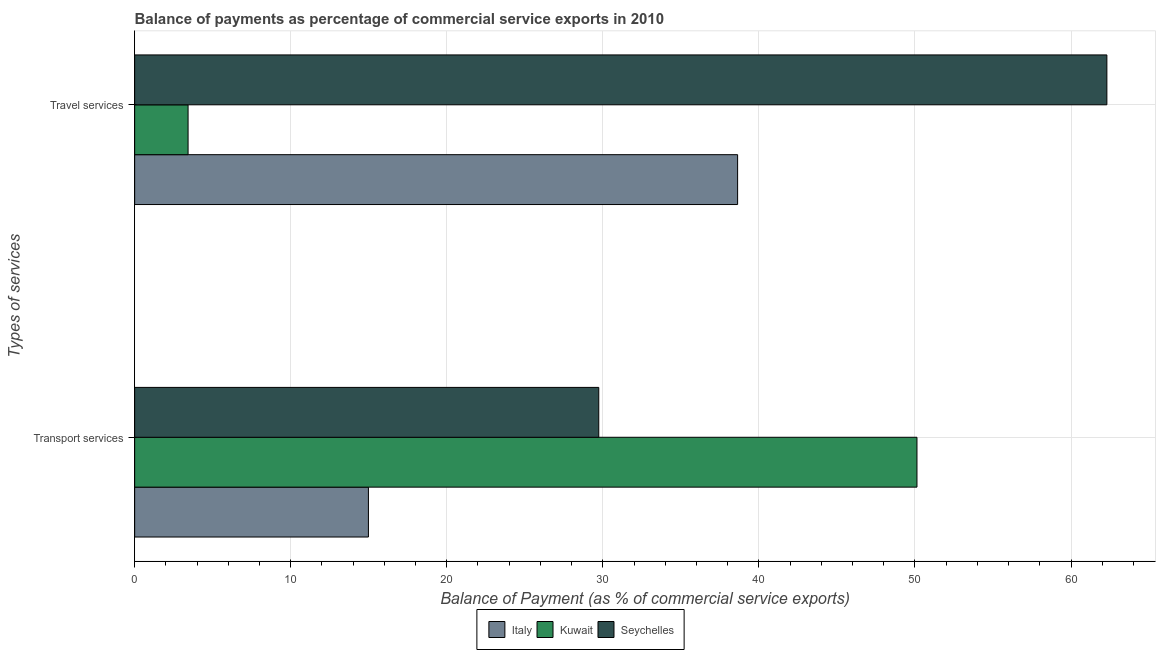How many different coloured bars are there?
Ensure brevity in your answer.  3. How many groups of bars are there?
Your answer should be very brief. 2. Are the number of bars per tick equal to the number of legend labels?
Provide a succinct answer. Yes. Are the number of bars on each tick of the Y-axis equal?
Keep it short and to the point. Yes. How many bars are there on the 2nd tick from the top?
Make the answer very short. 3. What is the label of the 2nd group of bars from the top?
Your answer should be very brief. Transport services. What is the balance of payments of travel services in Seychelles?
Ensure brevity in your answer.  62.3. Across all countries, what is the maximum balance of payments of travel services?
Offer a terse response. 62.3. Across all countries, what is the minimum balance of payments of transport services?
Offer a very short reply. 14.98. In which country was the balance of payments of travel services maximum?
Your answer should be compact. Seychelles. In which country was the balance of payments of travel services minimum?
Provide a short and direct response. Kuwait. What is the total balance of payments of travel services in the graph?
Offer a terse response. 104.36. What is the difference between the balance of payments of travel services in Italy and that in Seychelles?
Your answer should be very brief. -23.66. What is the difference between the balance of payments of transport services in Kuwait and the balance of payments of travel services in Seychelles?
Offer a very short reply. -12.17. What is the average balance of payments of travel services per country?
Provide a succinct answer. 34.79. What is the difference between the balance of payments of travel services and balance of payments of transport services in Seychelles?
Provide a short and direct response. 32.56. What is the ratio of the balance of payments of travel services in Kuwait to that in Seychelles?
Offer a very short reply. 0.05. In how many countries, is the balance of payments of travel services greater than the average balance of payments of travel services taken over all countries?
Provide a succinct answer. 2. What does the 2nd bar from the top in Travel services represents?
Offer a very short reply. Kuwait. What does the 3rd bar from the bottom in Travel services represents?
Provide a succinct answer. Seychelles. How many bars are there?
Offer a very short reply. 6. Are all the bars in the graph horizontal?
Provide a short and direct response. Yes. How many countries are there in the graph?
Make the answer very short. 3. Does the graph contain any zero values?
Keep it short and to the point. No. Where does the legend appear in the graph?
Provide a succinct answer. Bottom center. What is the title of the graph?
Your answer should be very brief. Balance of payments as percentage of commercial service exports in 2010. What is the label or title of the X-axis?
Your response must be concise. Balance of Payment (as % of commercial service exports). What is the label or title of the Y-axis?
Offer a terse response. Types of services. What is the Balance of Payment (as % of commercial service exports) in Italy in Transport services?
Provide a short and direct response. 14.98. What is the Balance of Payment (as % of commercial service exports) in Kuwait in Transport services?
Give a very brief answer. 50.13. What is the Balance of Payment (as % of commercial service exports) in Seychelles in Transport services?
Your answer should be compact. 29.74. What is the Balance of Payment (as % of commercial service exports) in Italy in Travel services?
Ensure brevity in your answer.  38.64. What is the Balance of Payment (as % of commercial service exports) in Kuwait in Travel services?
Give a very brief answer. 3.42. What is the Balance of Payment (as % of commercial service exports) in Seychelles in Travel services?
Your answer should be compact. 62.3. Across all Types of services, what is the maximum Balance of Payment (as % of commercial service exports) of Italy?
Offer a terse response. 38.64. Across all Types of services, what is the maximum Balance of Payment (as % of commercial service exports) in Kuwait?
Provide a succinct answer. 50.13. Across all Types of services, what is the maximum Balance of Payment (as % of commercial service exports) of Seychelles?
Your response must be concise. 62.3. Across all Types of services, what is the minimum Balance of Payment (as % of commercial service exports) in Italy?
Make the answer very short. 14.98. Across all Types of services, what is the minimum Balance of Payment (as % of commercial service exports) in Kuwait?
Ensure brevity in your answer.  3.42. Across all Types of services, what is the minimum Balance of Payment (as % of commercial service exports) in Seychelles?
Give a very brief answer. 29.74. What is the total Balance of Payment (as % of commercial service exports) in Italy in the graph?
Offer a very short reply. 53.62. What is the total Balance of Payment (as % of commercial service exports) in Kuwait in the graph?
Your response must be concise. 53.55. What is the total Balance of Payment (as % of commercial service exports) of Seychelles in the graph?
Provide a succinct answer. 92.04. What is the difference between the Balance of Payment (as % of commercial service exports) of Italy in Transport services and that in Travel services?
Keep it short and to the point. -23.66. What is the difference between the Balance of Payment (as % of commercial service exports) of Kuwait in Transport services and that in Travel services?
Your answer should be very brief. 46.7. What is the difference between the Balance of Payment (as % of commercial service exports) of Seychelles in Transport services and that in Travel services?
Offer a terse response. -32.56. What is the difference between the Balance of Payment (as % of commercial service exports) of Italy in Transport services and the Balance of Payment (as % of commercial service exports) of Kuwait in Travel services?
Provide a short and direct response. 11.56. What is the difference between the Balance of Payment (as % of commercial service exports) in Italy in Transport services and the Balance of Payment (as % of commercial service exports) in Seychelles in Travel services?
Make the answer very short. -47.32. What is the difference between the Balance of Payment (as % of commercial service exports) in Kuwait in Transport services and the Balance of Payment (as % of commercial service exports) in Seychelles in Travel services?
Provide a short and direct response. -12.17. What is the average Balance of Payment (as % of commercial service exports) in Italy per Types of services?
Ensure brevity in your answer.  26.81. What is the average Balance of Payment (as % of commercial service exports) of Kuwait per Types of services?
Your response must be concise. 26.78. What is the average Balance of Payment (as % of commercial service exports) of Seychelles per Types of services?
Ensure brevity in your answer.  46.02. What is the difference between the Balance of Payment (as % of commercial service exports) in Italy and Balance of Payment (as % of commercial service exports) in Kuwait in Transport services?
Offer a very short reply. -35.15. What is the difference between the Balance of Payment (as % of commercial service exports) in Italy and Balance of Payment (as % of commercial service exports) in Seychelles in Transport services?
Provide a succinct answer. -14.76. What is the difference between the Balance of Payment (as % of commercial service exports) of Kuwait and Balance of Payment (as % of commercial service exports) of Seychelles in Transport services?
Give a very brief answer. 20.39. What is the difference between the Balance of Payment (as % of commercial service exports) in Italy and Balance of Payment (as % of commercial service exports) in Kuwait in Travel services?
Your answer should be very brief. 35.21. What is the difference between the Balance of Payment (as % of commercial service exports) in Italy and Balance of Payment (as % of commercial service exports) in Seychelles in Travel services?
Keep it short and to the point. -23.66. What is the difference between the Balance of Payment (as % of commercial service exports) of Kuwait and Balance of Payment (as % of commercial service exports) of Seychelles in Travel services?
Give a very brief answer. -58.87. What is the ratio of the Balance of Payment (as % of commercial service exports) in Italy in Transport services to that in Travel services?
Make the answer very short. 0.39. What is the ratio of the Balance of Payment (as % of commercial service exports) of Kuwait in Transport services to that in Travel services?
Give a very brief answer. 14.64. What is the ratio of the Balance of Payment (as % of commercial service exports) in Seychelles in Transport services to that in Travel services?
Your answer should be very brief. 0.48. What is the difference between the highest and the second highest Balance of Payment (as % of commercial service exports) in Italy?
Make the answer very short. 23.66. What is the difference between the highest and the second highest Balance of Payment (as % of commercial service exports) in Kuwait?
Your answer should be compact. 46.7. What is the difference between the highest and the second highest Balance of Payment (as % of commercial service exports) of Seychelles?
Provide a short and direct response. 32.56. What is the difference between the highest and the lowest Balance of Payment (as % of commercial service exports) in Italy?
Your answer should be very brief. 23.66. What is the difference between the highest and the lowest Balance of Payment (as % of commercial service exports) of Kuwait?
Your response must be concise. 46.7. What is the difference between the highest and the lowest Balance of Payment (as % of commercial service exports) in Seychelles?
Keep it short and to the point. 32.56. 